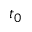<formula> <loc_0><loc_0><loc_500><loc_500>t _ { 0 }</formula> 